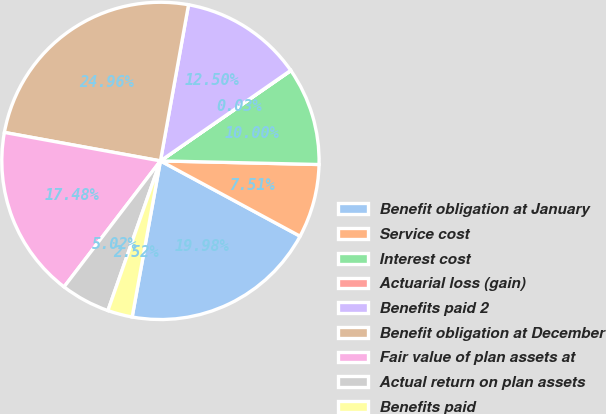Convert chart to OTSL. <chart><loc_0><loc_0><loc_500><loc_500><pie_chart><fcel>Benefit obligation at January<fcel>Service cost<fcel>Interest cost<fcel>Actuarial loss (gain)<fcel>Benefits paid 2<fcel>Benefit obligation at December<fcel>Fair value of plan assets at<fcel>Actual return on plan assets<fcel>Benefits paid<nl><fcel>19.98%<fcel>7.51%<fcel>10.0%<fcel>0.03%<fcel>12.5%<fcel>24.96%<fcel>17.48%<fcel>5.02%<fcel>2.52%<nl></chart> 